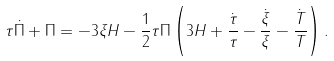Convert formula to latex. <formula><loc_0><loc_0><loc_500><loc_500>\tau \dot { \Pi } + \Pi = - 3 \xi H - \frac { 1 } { 2 } \tau \Pi \left ( 3 H + \frac { \dot { \tau } } { \tau } - \frac { \dot { \xi } } { \xi } - \frac { \dot { T } } { T } \right ) .</formula> 